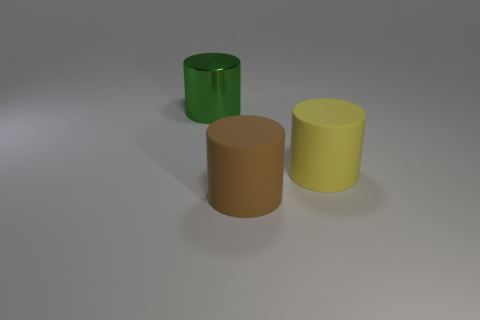Does the object that is to the right of the brown cylinder have the same size as the big brown cylinder?
Your answer should be very brief. Yes. What number of yellow objects are big metallic objects or large objects?
Your answer should be very brief. 1. There is a large brown cylinder that is in front of the large yellow matte cylinder; what is it made of?
Ensure brevity in your answer.  Rubber. How many large yellow objects are right of the matte cylinder on the right side of the large brown matte object?
Make the answer very short. 0. What number of big brown shiny objects are the same shape as the big yellow matte object?
Your answer should be compact. 0. What number of green cylinders are there?
Your answer should be very brief. 1. There is a big matte cylinder that is on the right side of the brown object; what is its color?
Give a very brief answer. Yellow. What color is the thing that is in front of the thing to the right of the big brown rubber object?
Provide a short and direct response. Brown. What color is the other shiny cylinder that is the same size as the yellow cylinder?
Your answer should be very brief. Green. What number of cylinders are both behind the brown rubber cylinder and right of the big green shiny thing?
Make the answer very short. 1. 